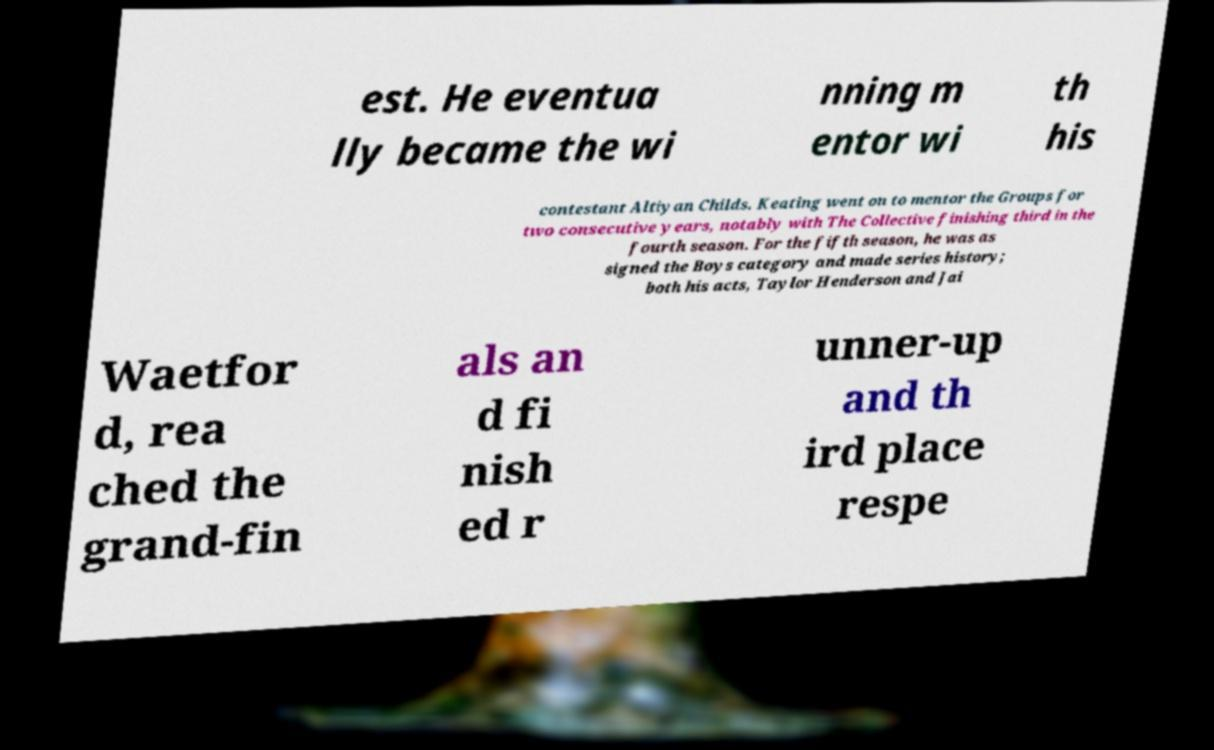Please read and relay the text visible in this image. What does it say? est. He eventua lly became the wi nning m entor wi th his contestant Altiyan Childs. Keating went on to mentor the Groups for two consecutive years, notably with The Collective finishing third in the fourth season. For the fifth season, he was as signed the Boys category and made series history; both his acts, Taylor Henderson and Jai Waetfor d, rea ched the grand-fin als an d fi nish ed r unner-up and th ird place respe 